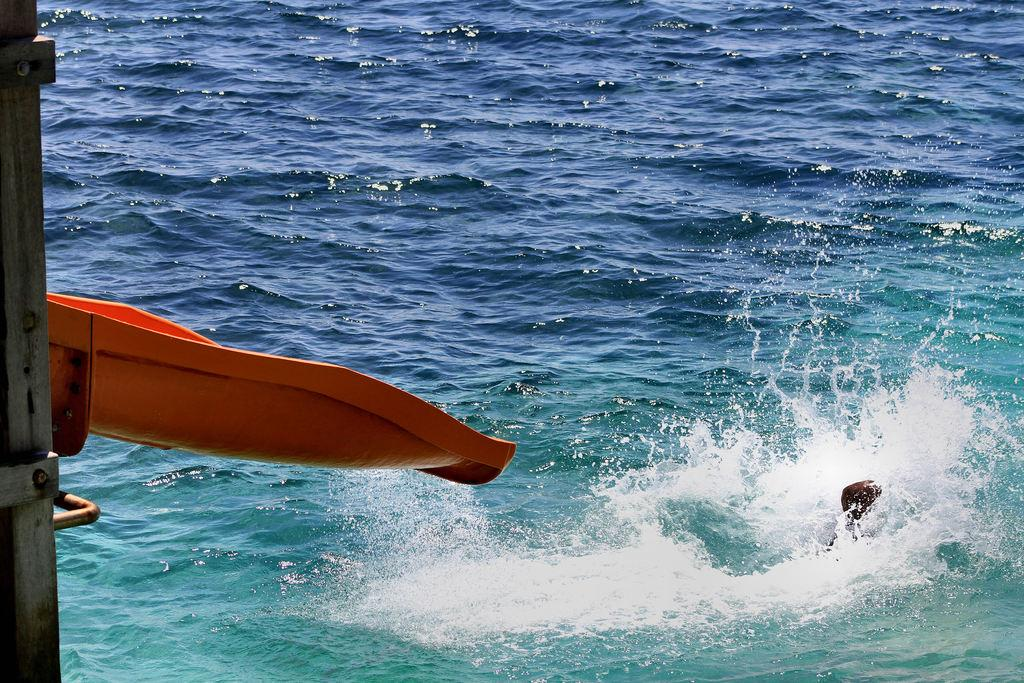What is the primary element visible in the image? There is water in the image. Can you describe any objects in the water? There is an object in the water on the right side. What type of recreational feature is visible on the left side of the image? There is a slide on the left side of the image. How many trees can be seen in the image? There is no tree present in the image. Is there a prison visible in the image? There is no prison present in the image. 